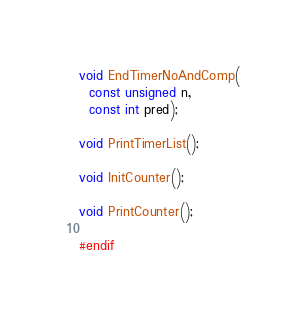<code> <loc_0><loc_0><loc_500><loc_500><_C_>void EndTimerNoAndComp(
  const unsigned n, 
  const int pred);

void PrintTimerList();

void InitCounter();

void PrintCounter();

#endif
</code> 